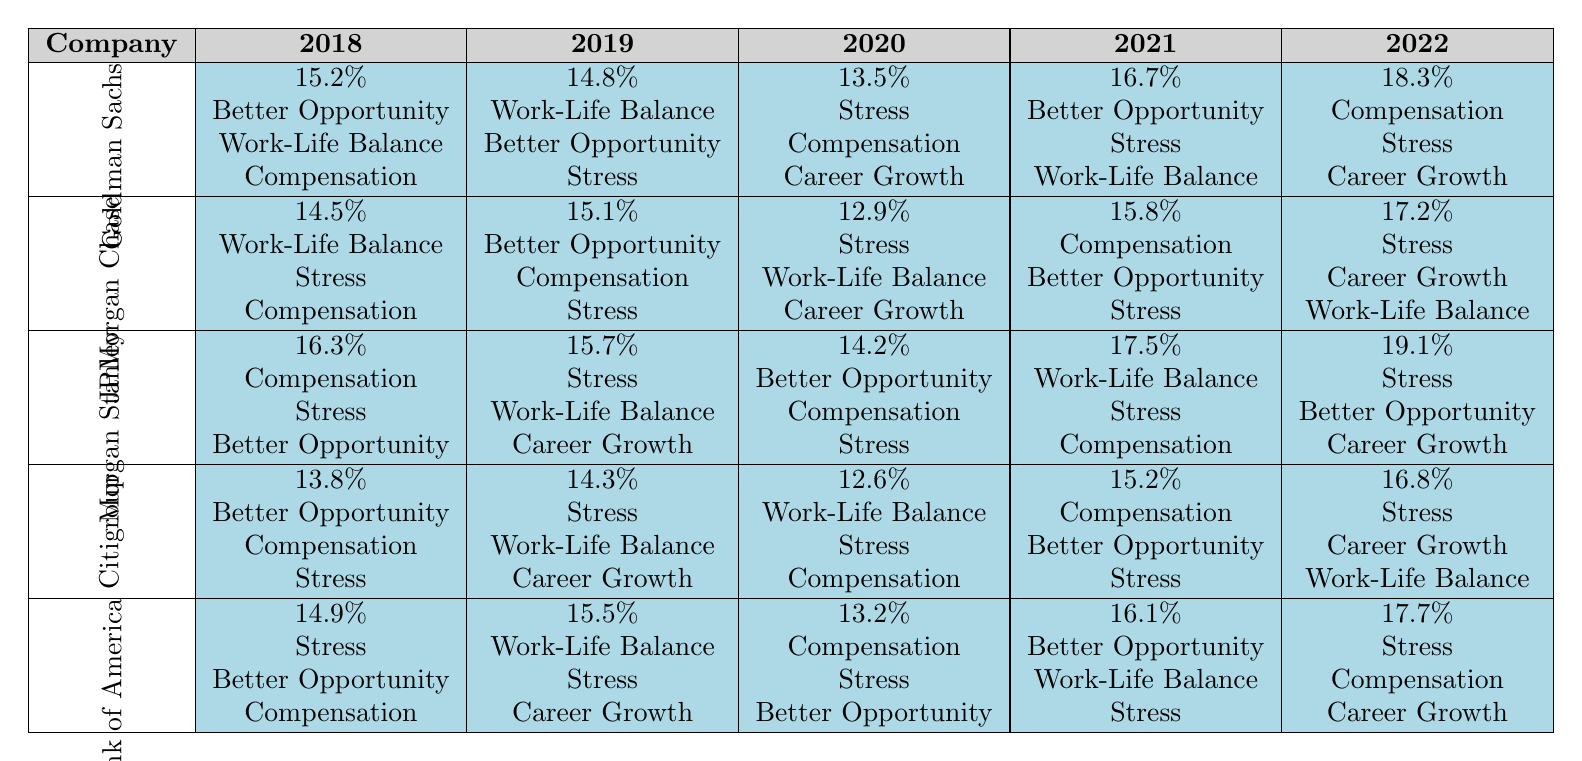What was the highest turnover rate recorded at Goldman Sachs? According to the table, the highest turnover rate for Goldman Sachs was 18.3%, which occurred in the year 2022.
Answer: 18.3% Which company had the lowest turnover rate in 2020? The table shows that Morgan Stanley had the lowest turnover rate in 2020 at 14.2%.
Answer: 14.2% Did the turnover rate at Citigroup increase or decrease from 2019 to 2020? The turnover rate at Citigroup increased from 14.3% in 2019 to 12.6% in 2020, which is a decrease in turnover rates.
Answer: Decrease What is the average turnover rate for JPMorgan Chase over the five years? The turnover rates for JPMorgan Chase are: 14.5%, 15.1%, 12.9%, 15.8%, and 17.2%. Summing these gives 75.5%, and dividing by 5 gives an average of 15.1%.
Answer: 15.1% Which firm had the most consistent turnover rates over the years? By comparing the turnover rates, Citigroup shows the smallest variation from 13.8% to 16.8% over the five years. This indicates relative consistency.
Answer: Citigroup What year saw the highest turnover rate across all companies? Checking the highest recorded rates per year, the highest overall was 19.1% in Morgan Stanley during 2022.
Answer: 19.1% In which year did the majority of companies cite "Stress" as a top reason for turnover? From the table, in 2022, three companies—Goldman Sachs, Citigroup, and Bank of America—cited "Stress" as a top reason for turnover.
Answer: 2022 What is the difference between the highest and lowest turnover rates at Bank of America? The turnover rates at Bank of America range from 14.9% in 2018 to 17.7% in 2022. The difference is 17.7% - 14.9% = 2.8%.
Answer: 2.8% How many times did "Compensation" appear as the top reason for turnover across all companies in 2021? In 2021, "Compensation" was the top reason for turnover for both Morgan Stanley and Citigroup. Therefore, it appeared twice.
Answer: 2 What percentage of the years did "Better Opportunity" rank as a top reason for Goldman Sachs? Looking at Goldman Sachs, "Better Opportunity" appears as a top reason in 2018 and 2021, which counts as 2 out of 5 years, equating to 40%.
Answer: 40% 